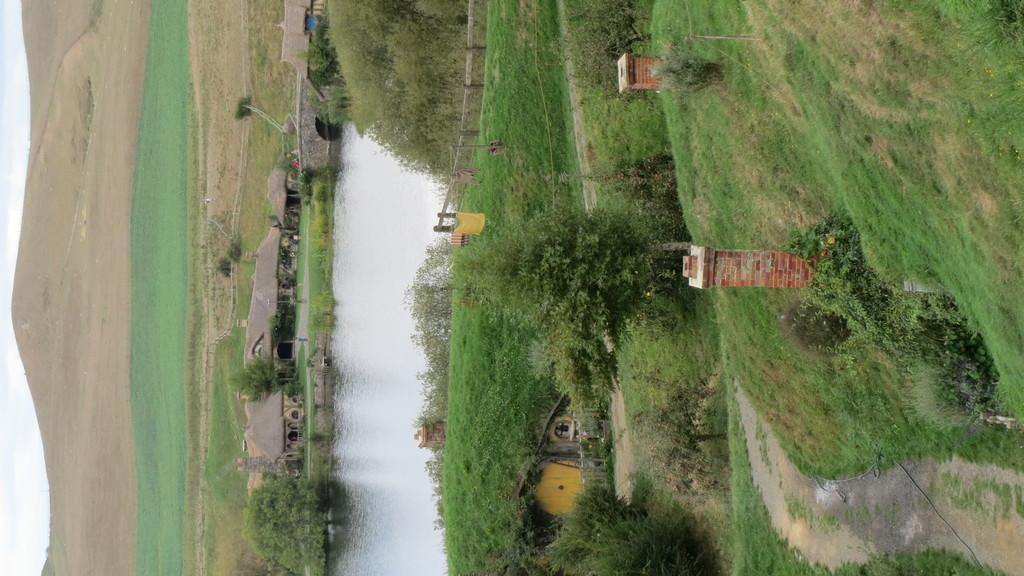Can you describe this image briefly? In the center I can see the lake. At the bottom I can see the buildings. Beside that I can see the trees, plants and grass. At the top I can see the wooden fencing. On the left I can see the farmland and mountains. In the bottom left corner I can see the sky and clouds. Beside the buildings I can see the road. In the top left I can see the bridge. 